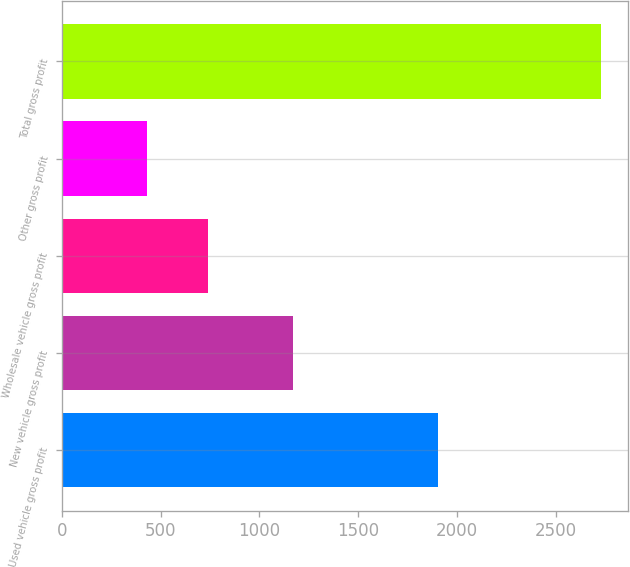<chart> <loc_0><loc_0><loc_500><loc_500><bar_chart><fcel>Used vehicle gross profit<fcel>New vehicle gross profit<fcel>Wholesale vehicle gross profit<fcel>Other gross profit<fcel>Total gross profit<nl><fcel>1903<fcel>1169<fcel>742<fcel>431<fcel>2731<nl></chart> 